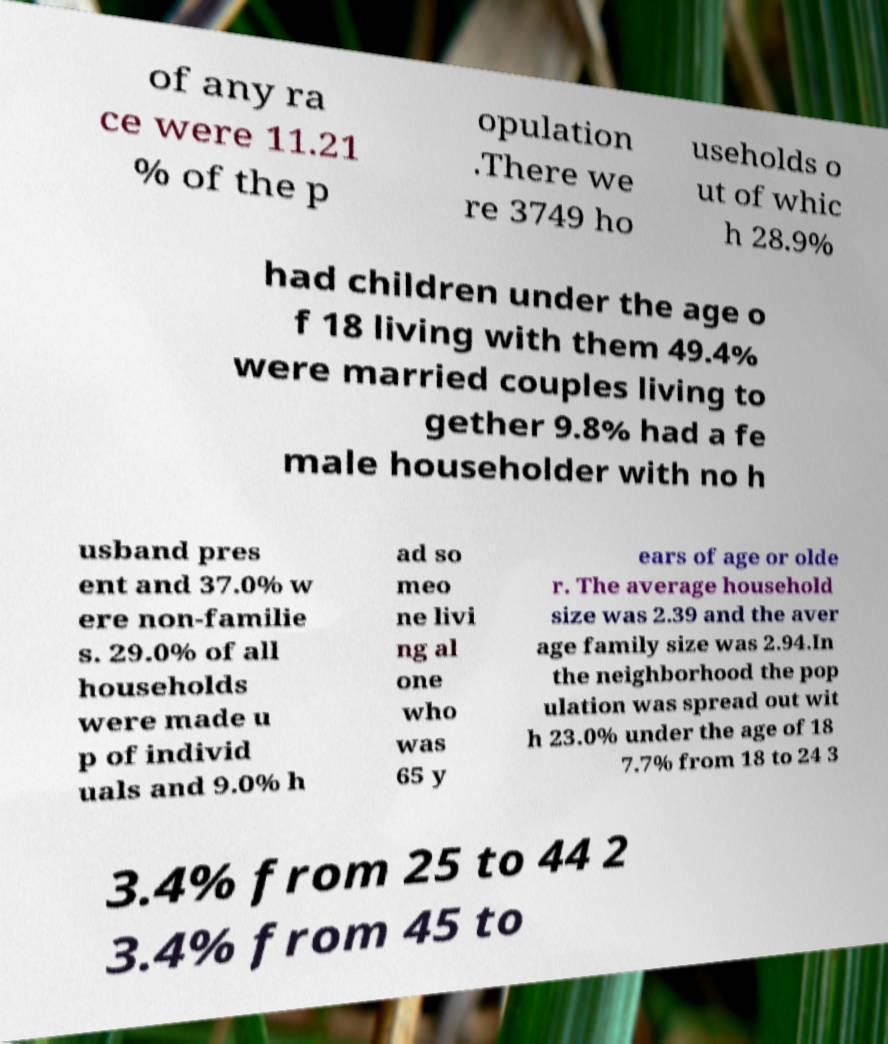I need the written content from this picture converted into text. Can you do that? of any ra ce were 11.21 % of the p opulation .There we re 3749 ho useholds o ut of whic h 28.9% had children under the age o f 18 living with them 49.4% were married couples living to gether 9.8% had a fe male householder with no h usband pres ent and 37.0% w ere non-familie s. 29.0% of all households were made u p of individ uals and 9.0% h ad so meo ne livi ng al one who was 65 y ears of age or olde r. The average household size was 2.39 and the aver age family size was 2.94.In the neighborhood the pop ulation was spread out wit h 23.0% under the age of 18 7.7% from 18 to 24 3 3.4% from 25 to 44 2 3.4% from 45 to 